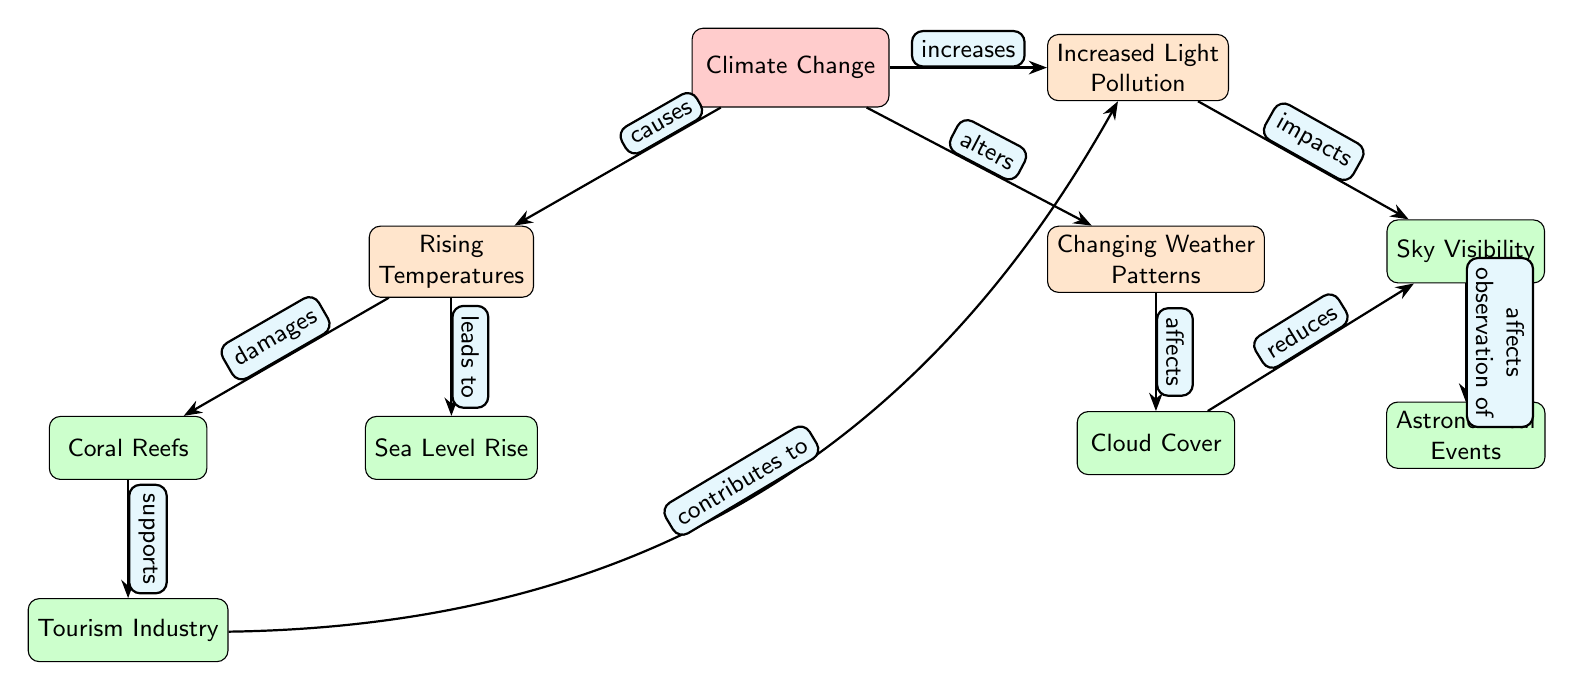What effect does Climate Change have on Coral Reefs? The diagram indicates that Rising Temperatures (an effect of Climate Change) damages Coral Reefs.
Answer: Damages How many impacts are associated with Light Pollution? By examining the diagram, we see that Light Pollution impacts only one direct effect, which is Sky Visibility.
Answer: 1 What causes Rising Temperatures? The diagram shows that Rising Temperatures are caused by Climate Change.
Answer: Climate Change What is the relationship between cloud cover and sky visibility? The diagram illustrates that cloud cover reduces sky visibility.
Answer: Reduces Which node directly affects the observation of astronomical events? The diagram indicates that Sky Visibility directly affects the observation of astronomical events.
Answer: Sky Visibility What influences rising temperatures according to the diagram? The diagram suggests that Climate Change influences rising temperatures, as indicated by the arrow pointing from Climate Change to Rising Temperatures.
Answer: Climate Change How does Tourism Industry relate to Light Pollution? The diagram explains that Tourism Industry contributes to Light Pollution through Coral Reefs, as it supports Coral Reefs, which then contributes to Light Pollution.
Answer: Contributes to What is the sequence of effects that arise from Changing Weather Patterns? Changing Weather Patterns leads to Cloud Cover, which then reduces Sky Visibility. This requires understanding the connections: Changing Weather Patterns alters Cloud Cover which in turn affects Sky Visibility.
Answer: Changing Weather Patterns → Cloud Cover → Reduces Sky Visibility How does climate change alter weather patterns? The diagram shows a direct arrow stating that Climate Change alters Weather Patterns, indicating a causative relationship.
Answer: Alters 